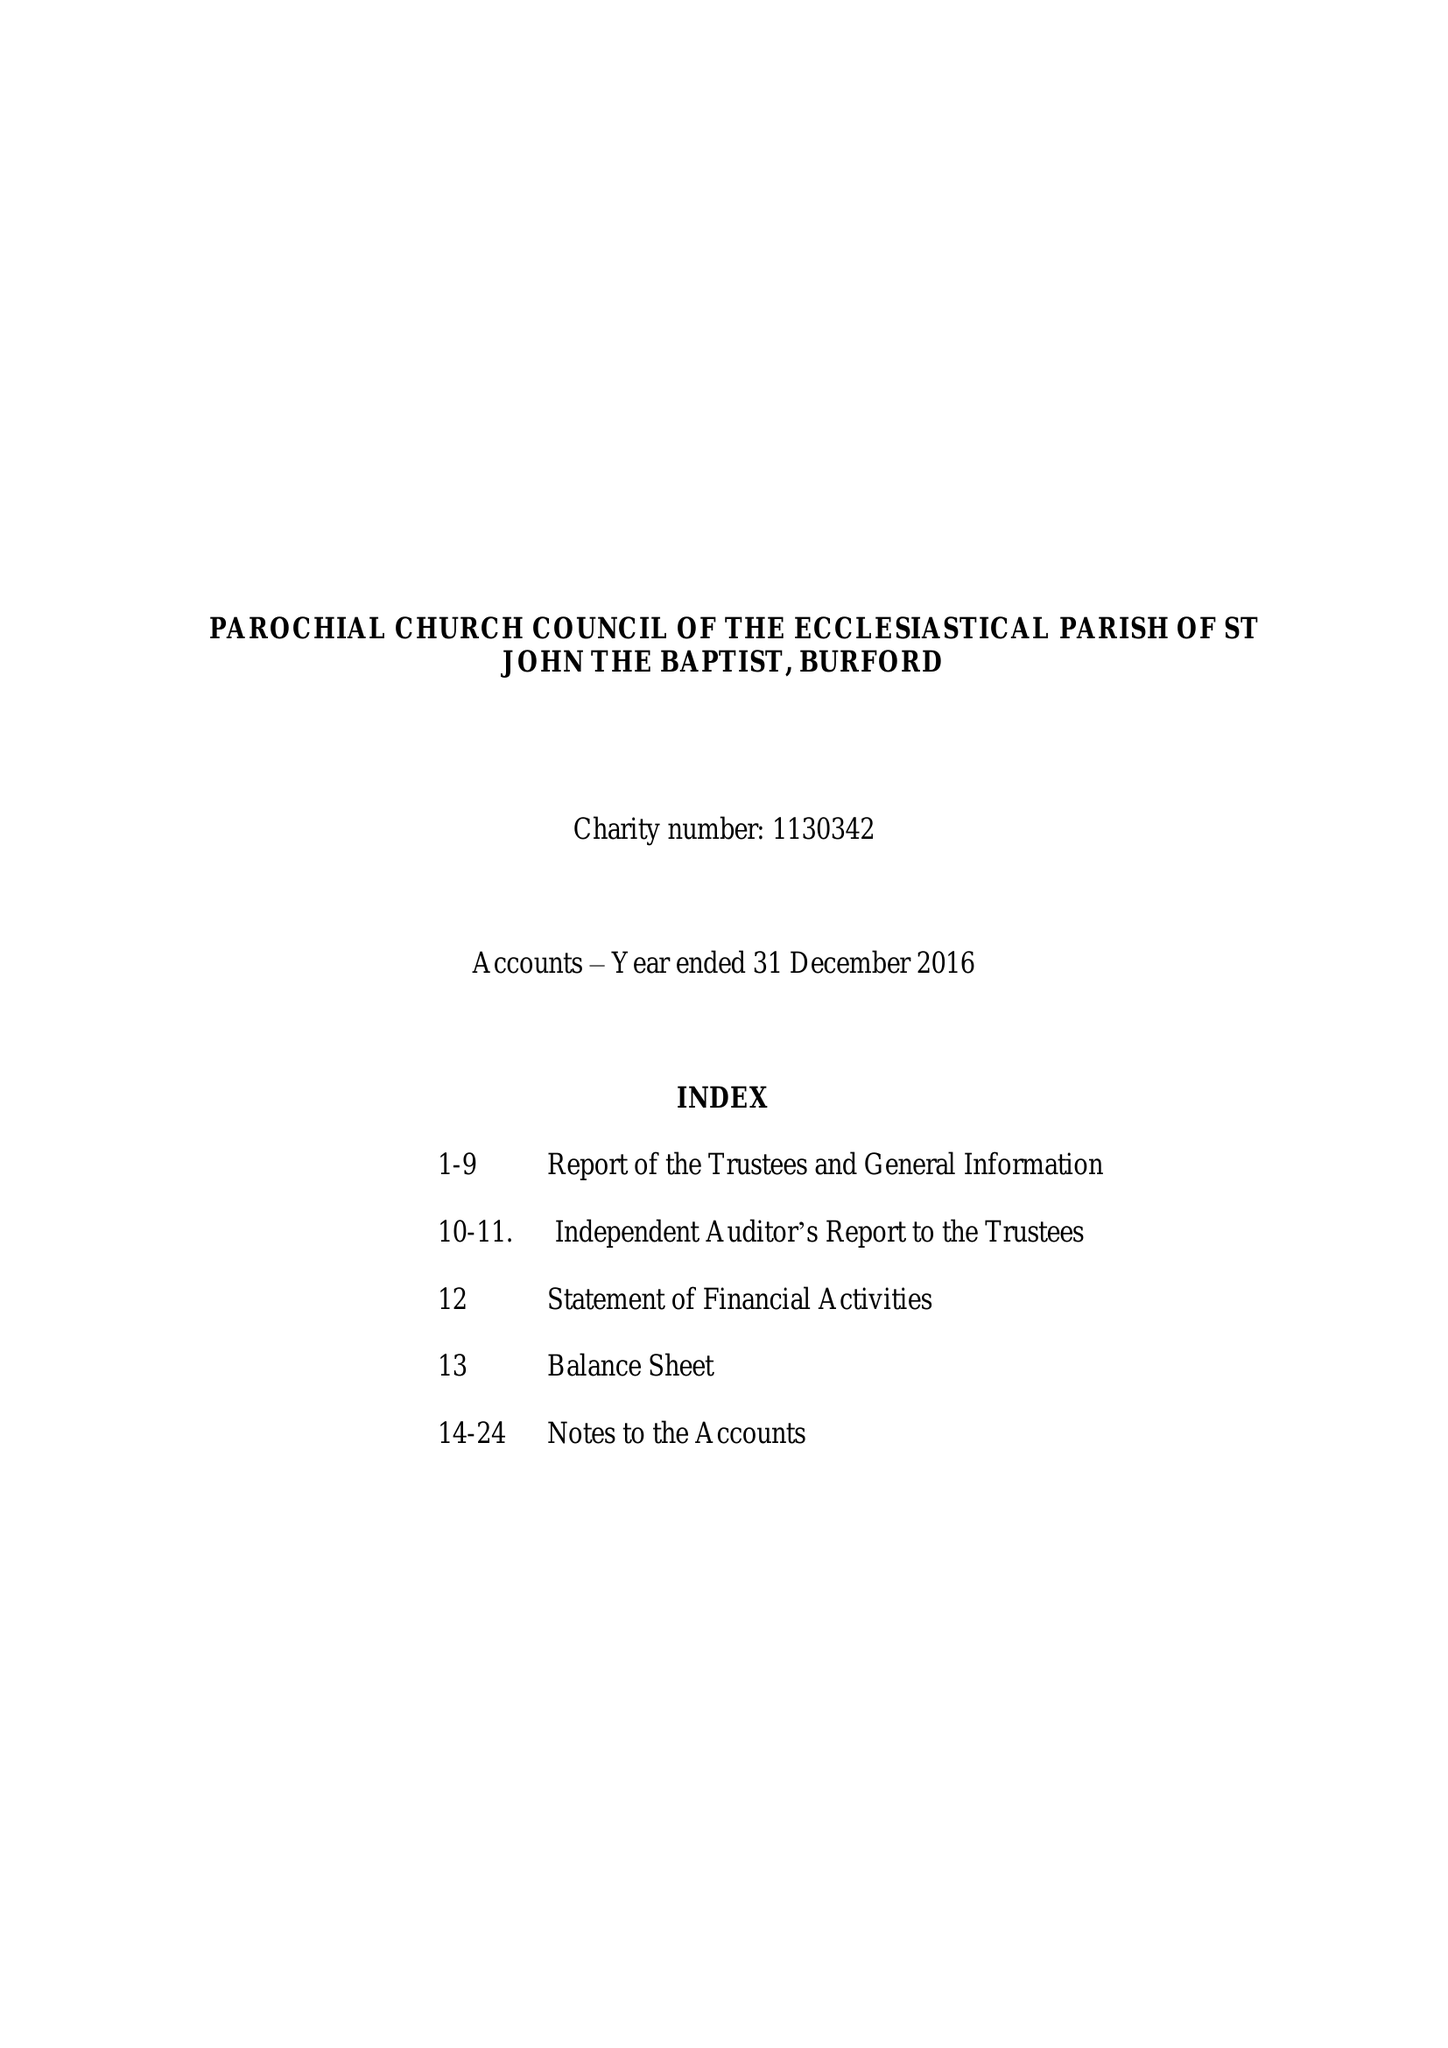What is the value for the address__postcode?
Answer the question using a single word or phrase. OX18 4RZ 